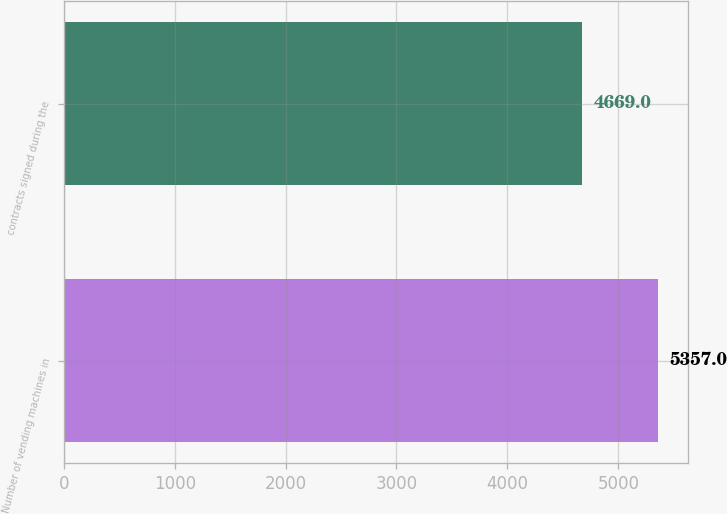Convert chart to OTSL. <chart><loc_0><loc_0><loc_500><loc_500><bar_chart><fcel>Number of vending machines in<fcel>contracts signed during the<nl><fcel>5357<fcel>4669<nl></chart> 